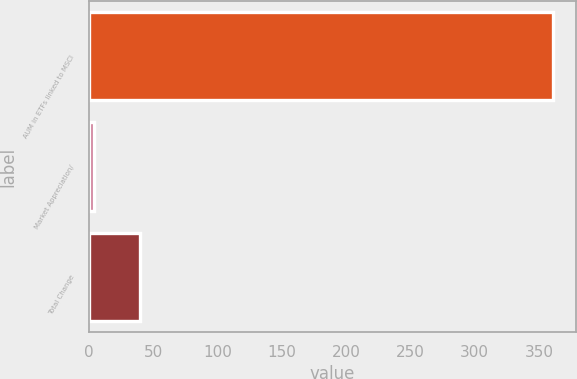<chart> <loc_0><loc_0><loc_500><loc_500><bar_chart><fcel>AUM in ETFs linked to MSCI<fcel>Market Appreciation/<fcel>Total Change<nl><fcel>360.5<fcel>3.8<fcel>39.47<nl></chart> 